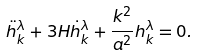<formula> <loc_0><loc_0><loc_500><loc_500>\ddot { h } ^ { \lambda } _ { k } + 3 H \dot { h } ^ { \lambda } _ { k } + \frac { k ^ { 2 } } { a ^ { 2 } } h ^ { \lambda } _ { k } = 0 .</formula> 